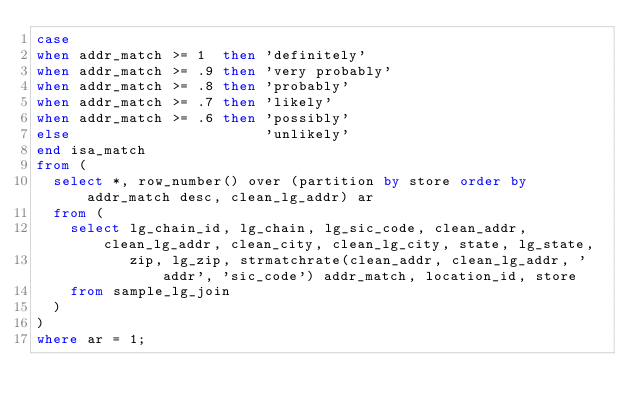<code> <loc_0><loc_0><loc_500><loc_500><_SQL_>case
when addr_match >= 1  then 'definitely'
when addr_match >= .9 then 'very probably'
when addr_match >= .8 then 'probably'
when addr_match >= .7 then 'likely'
when addr_match >= .6 then 'possibly'
else                       'unlikely'
end isa_match
from (
  select *, row_number() over (partition by store order by addr_match desc, clean_lg_addr) ar
  from (
    select lg_chain_id, lg_chain, lg_sic_code, clean_addr, clean_lg_addr, clean_city, clean_lg_city, state, lg_state,
           zip, lg_zip, strmatchrate(clean_addr, clean_lg_addr, 'addr', 'sic_code') addr_match, location_id, store
    from sample_lg_join
  )
)
where ar = 1;
</code> 